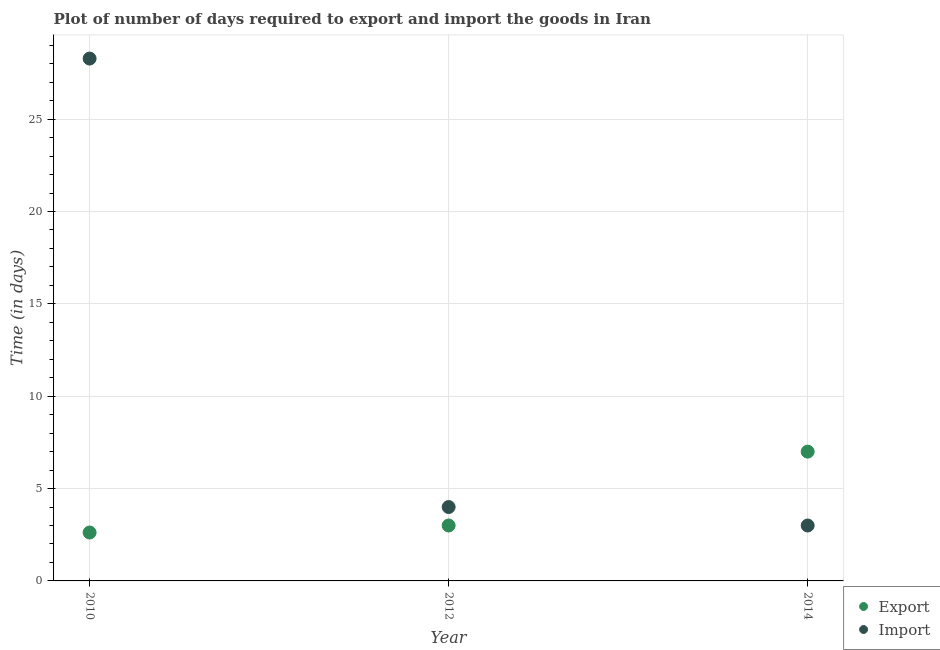How many different coloured dotlines are there?
Provide a short and direct response. 2. Is the number of dotlines equal to the number of legend labels?
Your answer should be compact. Yes. What is the time required to export in 2014?
Keep it short and to the point. 7. Across all years, what is the maximum time required to import?
Offer a very short reply. 28.28. In which year was the time required to import maximum?
Offer a terse response. 2010. In which year was the time required to export minimum?
Make the answer very short. 2010. What is the total time required to export in the graph?
Offer a very short reply. 12.62. What is the difference between the time required to export in 2012 and that in 2014?
Keep it short and to the point. -4. What is the difference between the time required to import in 2010 and the time required to export in 2014?
Your response must be concise. 21.28. What is the average time required to export per year?
Your answer should be very brief. 4.21. In how many years, is the time required to export greater than 10 days?
Your answer should be compact. 0. What is the ratio of the time required to export in 2010 to that in 2014?
Give a very brief answer. 0.37. Is the time required to export in 2010 less than that in 2012?
Give a very brief answer. Yes. Is the difference between the time required to import in 2012 and 2014 greater than the difference between the time required to export in 2012 and 2014?
Your answer should be very brief. Yes. What is the difference between the highest and the second highest time required to import?
Your response must be concise. 24.28. What is the difference between the highest and the lowest time required to import?
Your answer should be very brief. 25.28. Is the sum of the time required to export in 2010 and 2012 greater than the maximum time required to import across all years?
Provide a succinct answer. No. Is the time required to export strictly greater than the time required to import over the years?
Your answer should be very brief. No. Is the time required to export strictly less than the time required to import over the years?
Provide a short and direct response. No. How many dotlines are there?
Your answer should be compact. 2. Are the values on the major ticks of Y-axis written in scientific E-notation?
Give a very brief answer. No. Does the graph contain any zero values?
Your answer should be very brief. No. How many legend labels are there?
Your answer should be compact. 2. What is the title of the graph?
Give a very brief answer. Plot of number of days required to export and import the goods in Iran. Does "National Tourists" appear as one of the legend labels in the graph?
Offer a terse response. No. What is the label or title of the X-axis?
Your response must be concise. Year. What is the label or title of the Y-axis?
Your response must be concise. Time (in days). What is the Time (in days) in Export in 2010?
Ensure brevity in your answer.  2.62. What is the Time (in days) in Import in 2010?
Offer a very short reply. 28.28. What is the Time (in days) in Export in 2014?
Your response must be concise. 7. Across all years, what is the maximum Time (in days) in Import?
Ensure brevity in your answer.  28.28. Across all years, what is the minimum Time (in days) in Export?
Offer a very short reply. 2.62. What is the total Time (in days) of Export in the graph?
Your answer should be compact. 12.62. What is the total Time (in days) in Import in the graph?
Provide a succinct answer. 35.28. What is the difference between the Time (in days) of Export in 2010 and that in 2012?
Give a very brief answer. -0.38. What is the difference between the Time (in days) in Import in 2010 and that in 2012?
Your answer should be very brief. 24.28. What is the difference between the Time (in days) in Export in 2010 and that in 2014?
Provide a short and direct response. -4.38. What is the difference between the Time (in days) in Import in 2010 and that in 2014?
Make the answer very short. 25.28. What is the difference between the Time (in days) in Export in 2012 and that in 2014?
Provide a succinct answer. -4. What is the difference between the Time (in days) of Export in 2010 and the Time (in days) of Import in 2012?
Your answer should be very brief. -1.38. What is the difference between the Time (in days) of Export in 2010 and the Time (in days) of Import in 2014?
Give a very brief answer. -0.38. What is the average Time (in days) of Export per year?
Offer a terse response. 4.21. What is the average Time (in days) of Import per year?
Offer a terse response. 11.76. In the year 2010, what is the difference between the Time (in days) in Export and Time (in days) in Import?
Give a very brief answer. -25.66. What is the ratio of the Time (in days) in Export in 2010 to that in 2012?
Make the answer very short. 0.87. What is the ratio of the Time (in days) of Import in 2010 to that in 2012?
Offer a terse response. 7.07. What is the ratio of the Time (in days) of Export in 2010 to that in 2014?
Provide a short and direct response. 0.37. What is the ratio of the Time (in days) of Import in 2010 to that in 2014?
Offer a terse response. 9.43. What is the ratio of the Time (in days) of Export in 2012 to that in 2014?
Your answer should be very brief. 0.43. What is the difference between the highest and the second highest Time (in days) in Export?
Ensure brevity in your answer.  4. What is the difference between the highest and the second highest Time (in days) of Import?
Give a very brief answer. 24.28. What is the difference between the highest and the lowest Time (in days) in Export?
Give a very brief answer. 4.38. What is the difference between the highest and the lowest Time (in days) in Import?
Provide a short and direct response. 25.28. 